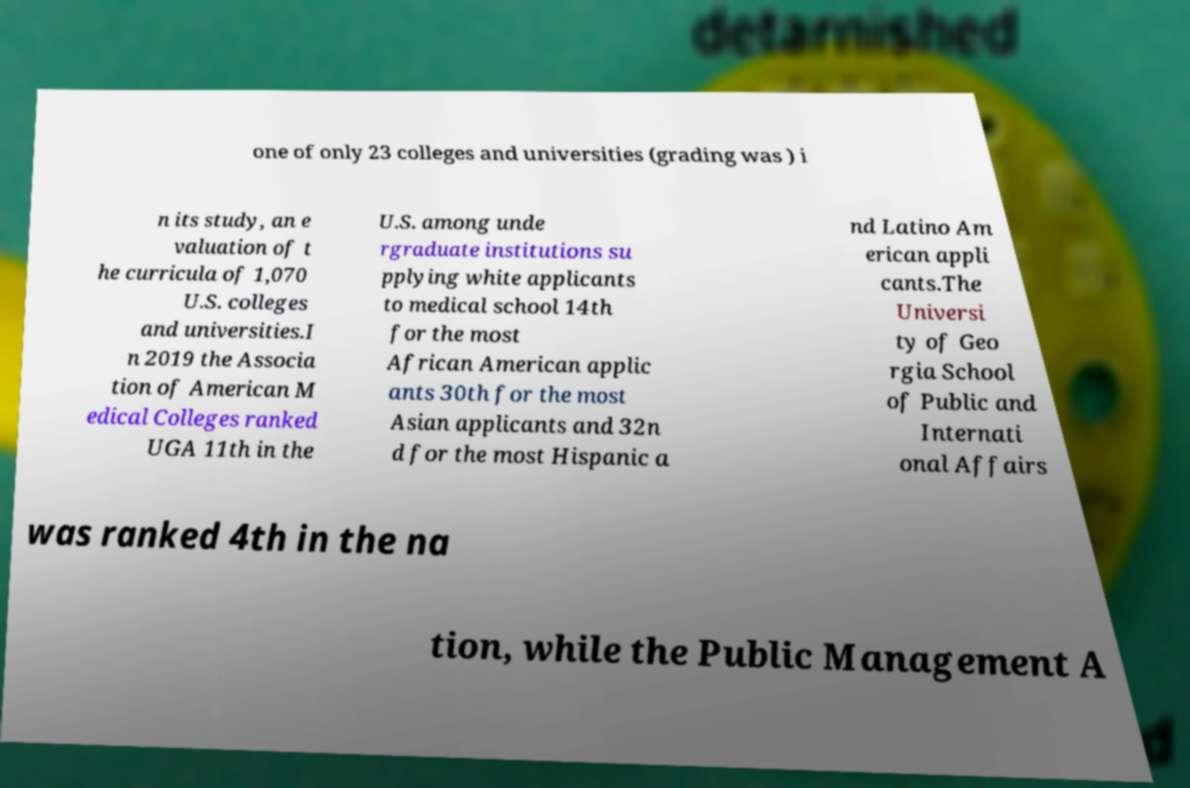Please identify and transcribe the text found in this image. one of only 23 colleges and universities (grading was ) i n its study, an e valuation of t he curricula of 1,070 U.S. colleges and universities.I n 2019 the Associa tion of American M edical Colleges ranked UGA 11th in the U.S. among unde rgraduate institutions su pplying white applicants to medical school 14th for the most African American applic ants 30th for the most Asian applicants and 32n d for the most Hispanic a nd Latino Am erican appli cants.The Universi ty of Geo rgia School of Public and Internati onal Affairs was ranked 4th in the na tion, while the Public Management A 